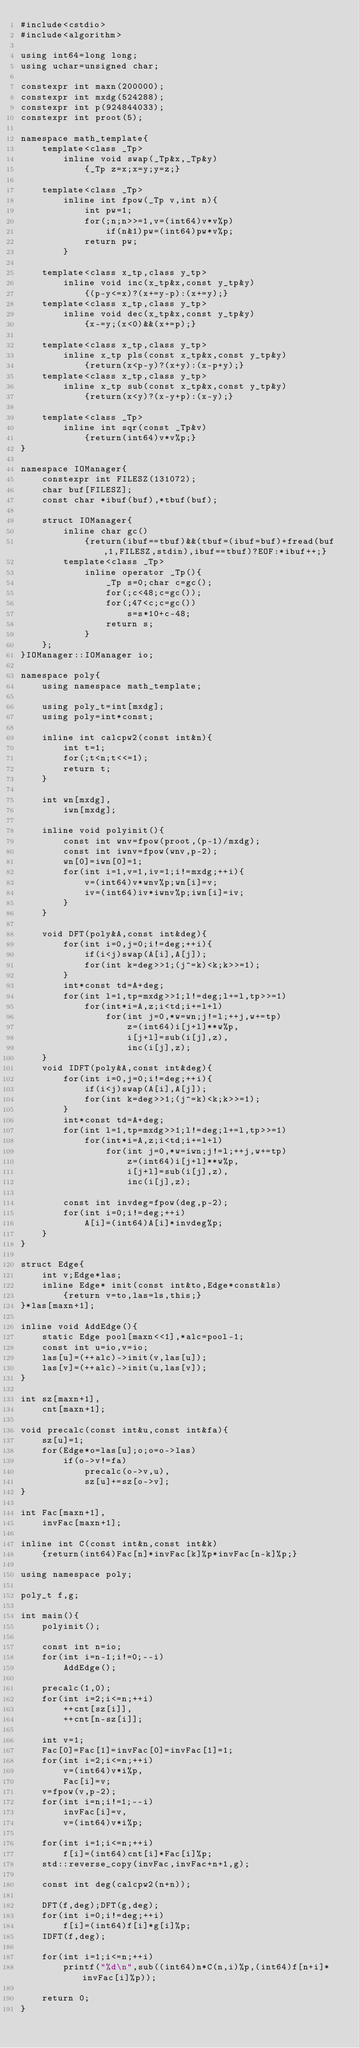Convert code to text. <code><loc_0><loc_0><loc_500><loc_500><_C++_>#include<cstdio>
#include<algorithm>

using int64=long long;
using uchar=unsigned char;

constexpr int maxn(200000);
constexpr int mxdg(524288);
constexpr int p(924844033);
constexpr int proot(5);

namespace math_template{
	template<class _Tp>
		inline void swap(_Tp&x,_Tp&y)
			{_Tp z=x;x=y;y=z;}

	template<class _Tp>
		inline int fpow(_Tp v,int n){
			int pw=1;
			for(;n;n>>=1,v=(int64)v*v%p)
				if(n&1)pw=(int64)pw*v%p;
			return pw;
		}

	template<class x_tp,class y_tp>
		inline void inc(x_tp&x,const y_tp&y)
			{(p-y<=x)?(x+=y-p):(x+=y);}
	template<class x_tp,class y_tp>
		inline void dec(x_tp&x,const y_tp&y)
			{x-=y;(x<0)&&(x+=p);}

	template<class x_tp,class y_tp>
		inline x_tp pls(const x_tp&x,const y_tp&y)
			{return(x<p-y)?(x+y):(x-p+y);}
	template<class x_tp,class y_tp>
		inline x_tp sub(const x_tp&x,const y_tp&y)
			{return(x<y)?(x-y+p):(x-y);}

	template<class _Tp>
		inline int sqr(const _Tp&v)
			{return(int64)v*v%p;}
}

namespace IOManager{
	constexpr int FILESZ(131072);
	char buf[FILESZ];
	const char *ibuf(buf),*tbuf(buf);

	struct IOManager{
		inline char gc()
			{return(ibuf==tbuf)&&(tbuf=(ibuf=buf)+fread(buf,1,FILESZ,stdin),ibuf==tbuf)?EOF:*ibuf++;}
		template<class _Tp>
			inline operator _Tp(){
				_Tp s=0;char c=gc();
				for(;c<48;c=gc());
				for(;47<c;c=gc())
					s=s*10+c-48;
				return s;
			}
	};
}IOManager::IOManager io;

namespace poly{
	using namespace math_template;

	using poly_t=int[mxdg];
	using poly=int*const;

	inline int calcpw2(const int&n){
		int t=1;
		for(;t<n;t<<=1);
		return t;
	}

	int wn[mxdg],
		iwn[mxdg];

	inline void polyinit(){
		const int wnv=fpow(proot,(p-1)/mxdg);
		const int iwnv=fpow(wnv,p-2);
		wn[0]=iwn[0]=1;
		for(int i=1,v=1,iv=1;i!=mxdg;++i){
			v=(int64)v*wnv%p;wn[i]=v;
			iv=(int64)iv*iwnv%p;iwn[i]=iv;
		}
	}

	void DFT(poly&A,const int&deg){
		for(int i=0,j=0;i!=deg;++i){
			if(i<j)swap(A[i],A[j]);
			for(int k=deg>>1;(j^=k)<k;k>>=1);
		}
		int*const td=A+deg;
		for(int l=1,tp=mxdg>>1;l!=deg;l+=l,tp>>=1)
			for(int*i=A,z;i<td;i+=l+l)
				for(int j=0,*w=wn;j!=l;++j,w+=tp)
					z=(int64)i[j+l]**w%p,
					i[j+l]=sub(i[j],z),
					inc(i[j],z);
	}
	void IDFT(poly&A,const int&deg){
		for(int i=0,j=0;i!=deg;++i){
			if(i<j)swap(A[i],A[j]);
			for(int k=deg>>1;(j^=k)<k;k>>=1);
		}
		int*const td=A+deg;
		for(int l=1,tp=mxdg>>1;l!=deg;l+=l,tp>>=1)
			for(int*i=A,z;i<td;i+=l+l)
				for(int j=0,*w=iwn;j!=l;++j,w+=tp)
					z=(int64)i[j+l]**w%p,
					i[j+l]=sub(i[j],z),
					inc(i[j],z);

		const int invdeg=fpow(deg,p-2);
		for(int i=0;i!=deg;++i)
			A[i]=(int64)A[i]*invdeg%p;
	}
}

struct Edge{
	int v;Edge*las;
	inline Edge* init(const int&to,Edge*const&ls)
		{return v=to,las=ls,this;}
}*las[maxn+1];

inline void AddEdge(){
	static Edge pool[maxn<<1],*alc=pool-1;
	const int u=io,v=io;
	las[u]=(++alc)->init(v,las[u]);
	las[v]=(++alc)->init(u,las[v]);
}

int sz[maxn+1],
	cnt[maxn+1];

void precalc(const int&u,const int&fa){
	sz[u]=1;
	for(Edge*o=las[u];o;o=o->las)
		if(o->v!=fa)
			precalc(o->v,u),
			sz[u]+=sz[o->v];
}

int Fac[maxn+1],
	invFac[maxn+1];

inline int C(const int&n,const int&k)
	{return(int64)Fac[n]*invFac[k]%p*invFac[n-k]%p;}

using namespace poly;

poly_t f,g;

int main(){
	polyinit();

	const int n=io;
	for(int i=n-1;i!=0;--i)
		AddEdge();

	precalc(1,0);
	for(int i=2;i<=n;++i)
		++cnt[sz[i]],
		++cnt[n-sz[i]];

	int v=1;
	Fac[0]=Fac[1]=invFac[0]=invFac[1]=1;
	for(int i=2;i<=n;++i)
		v=(int64)v*i%p,
		Fac[i]=v;
	v=fpow(v,p-2);
	for(int i=n;i!=1;--i)
		invFac[i]=v,
		v=(int64)v*i%p;

	for(int i=1;i<=n;++i)
		f[i]=(int64)cnt[i]*Fac[i]%p;
	std::reverse_copy(invFac,invFac+n+1,g);

	const int deg(calcpw2(n+n));

	DFT(f,deg);DFT(g,deg);
	for(int i=0;i!=deg;++i)
		f[i]=(int64)f[i]*g[i]%p;
	IDFT(f,deg);

	for(int i=1;i<=n;++i)
		printf("%d\n",sub((int64)n*C(n,i)%p,(int64)f[n+i]*invFac[i]%p));

	return 0;
}
</code> 